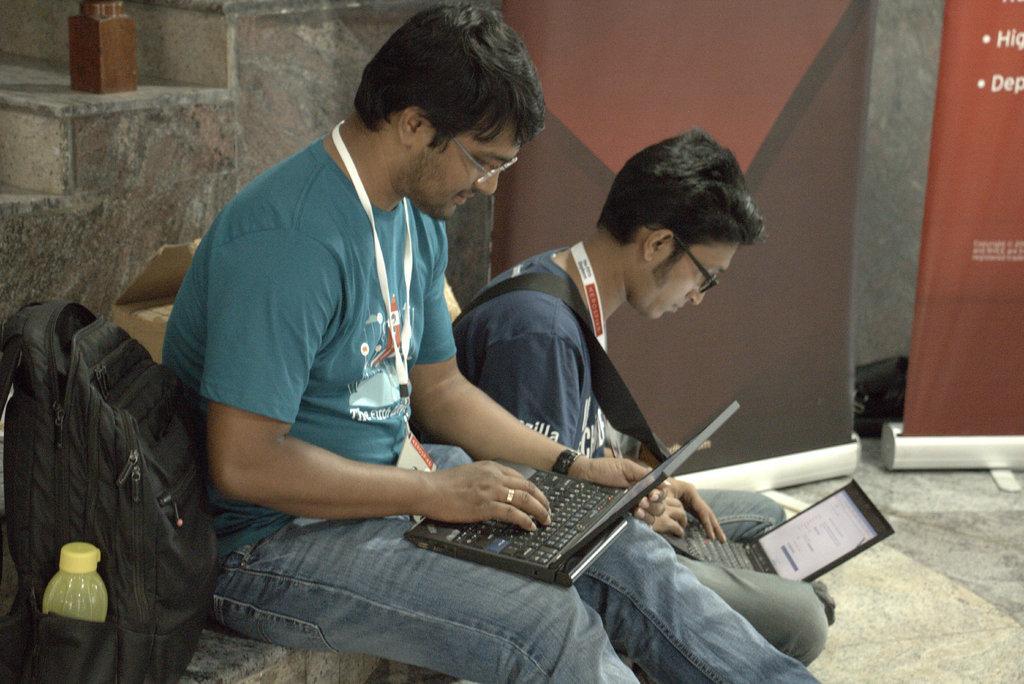Can you describe this image briefly? In this image I can see two people are holding laptops. I can see the bag on the bench. Back I can see few banners and few stairs. 